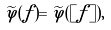<formula> <loc_0><loc_0><loc_500><loc_500>\widetilde { \varphi } ( f ) = \widetilde { \varphi } ( [ f ] ) ,</formula> 